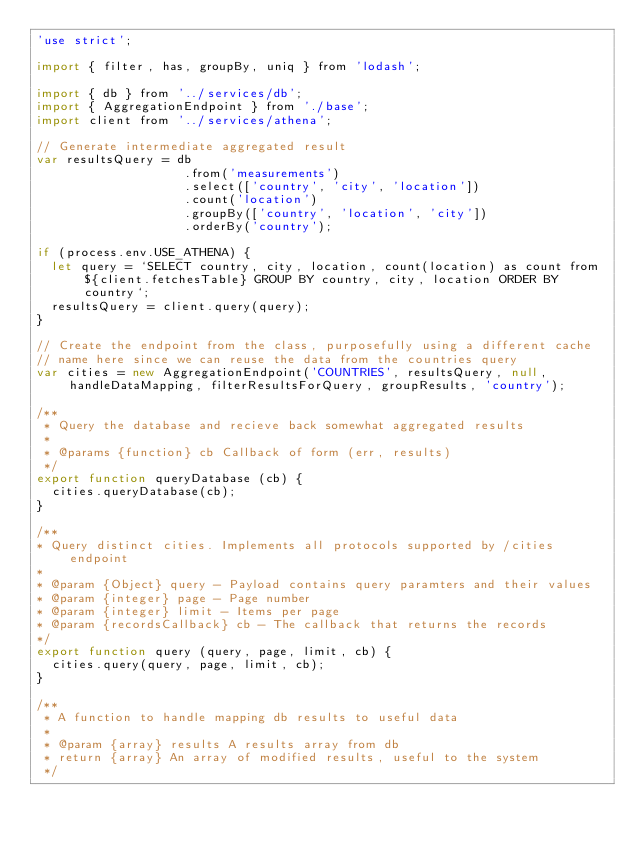Convert code to text. <code><loc_0><loc_0><loc_500><loc_500><_JavaScript_>'use strict';

import { filter, has, groupBy, uniq } from 'lodash';

import { db } from '../services/db';
import { AggregationEndpoint } from './base';
import client from '../services/athena';

// Generate intermediate aggregated result
var resultsQuery = db
                    .from('measurements')
                    .select(['country', 'city', 'location'])
                    .count('location')
                    .groupBy(['country', 'location', 'city'])
                    .orderBy('country');

if (process.env.USE_ATHENA) {
  let query = `SELECT country, city, location, count(location) as count from ${client.fetchesTable} GROUP BY country, city, location ORDER BY country`;
  resultsQuery = client.query(query);
}

// Create the endpoint from the class, purposefully using a different cache
// name here since we can reuse the data from the countries query
var cities = new AggregationEndpoint('COUNTRIES', resultsQuery, null, handleDataMapping, filterResultsForQuery, groupResults, 'country');

/**
 * Query the database and recieve back somewhat aggregated results
 *
 * @params {function} cb Callback of form (err, results)
 */
export function queryDatabase (cb) {
  cities.queryDatabase(cb);
}

/**
* Query distinct cities. Implements all protocols supported by /cities endpoint
*
* @param {Object} query - Payload contains query paramters and their values
* @param {integer} page - Page number
* @param {integer} limit - Items per page
* @param {recordsCallback} cb - The callback that returns the records
*/
export function query (query, page, limit, cb) {
  cities.query(query, page, limit, cb);
}

/**
 * A function to handle mapping db results to useful data
 *
 * @param {array} results A results array from db
 * return {array} An array of modified results, useful to the system
 */</code> 